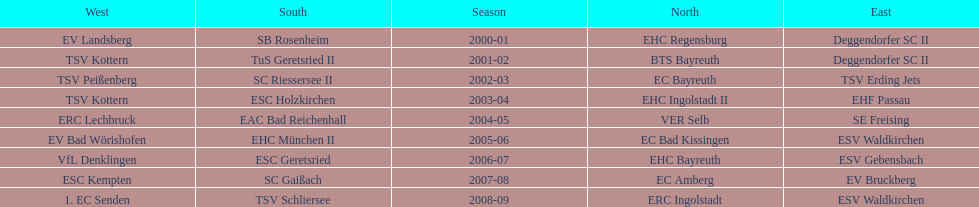What is the number of times deggendorfer sc ii is on the list? 2. 